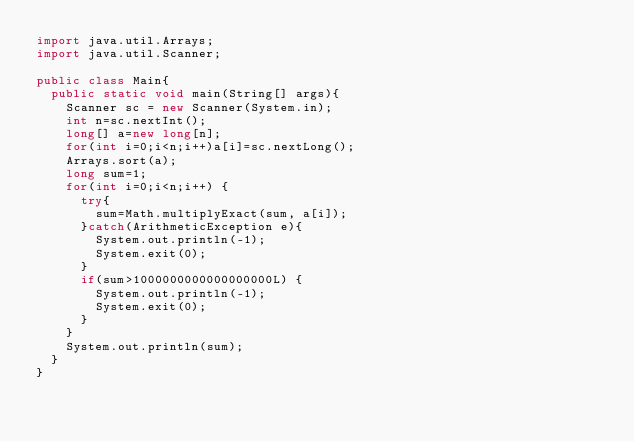<code> <loc_0><loc_0><loc_500><loc_500><_Java_>import java.util.Arrays;
import java.util.Scanner;

public class Main{
  public static void main(String[] args){
	  Scanner sc = new Scanner(System.in);
	  int n=sc.nextInt();
	  long[] a=new long[n];
	  for(int i=0;i<n;i++)a[i]=sc.nextLong();
	  Arrays.sort(a);
	  long sum=1;
	  for(int i=0;i<n;i++) {
		  try{
			  sum=Math.multiplyExact(sum, a[i]);
		  }catch(ArithmeticException e){
			  System.out.println(-1);
			  System.exit(0);
		  }
		  if(sum>1000000000000000000L) {
			  System.out.println(-1);
			  System.exit(0);
		  }
	  }
	  System.out.println(sum);
  }
}

</code> 